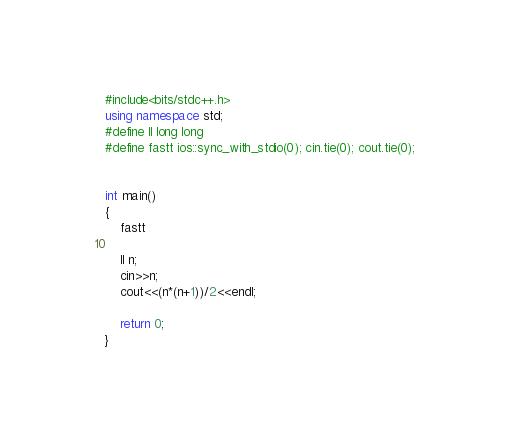Convert code to text. <code><loc_0><loc_0><loc_500><loc_500><_C++_>#include<bits/stdc++.h>
using namespace std;
#define ll long long
#define fastt ios::sync_with_stdio(0); cin.tie(0); cout.tie(0);


int main()
{
	fastt

	ll n;
	cin>>n;
	cout<<(n*(n+1))/2<<endl;

	return 0;
}

</code> 